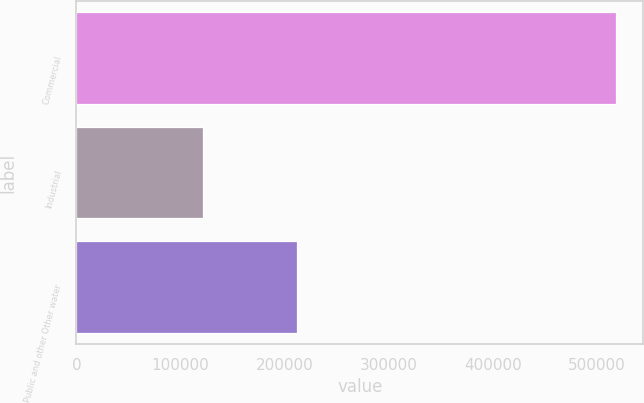<chart> <loc_0><loc_0><loc_500><loc_500><bar_chart><fcel>Commercial<fcel>Industrial<fcel>Public and other Other water<nl><fcel>518253<fcel>121902<fcel>212289<nl></chart> 